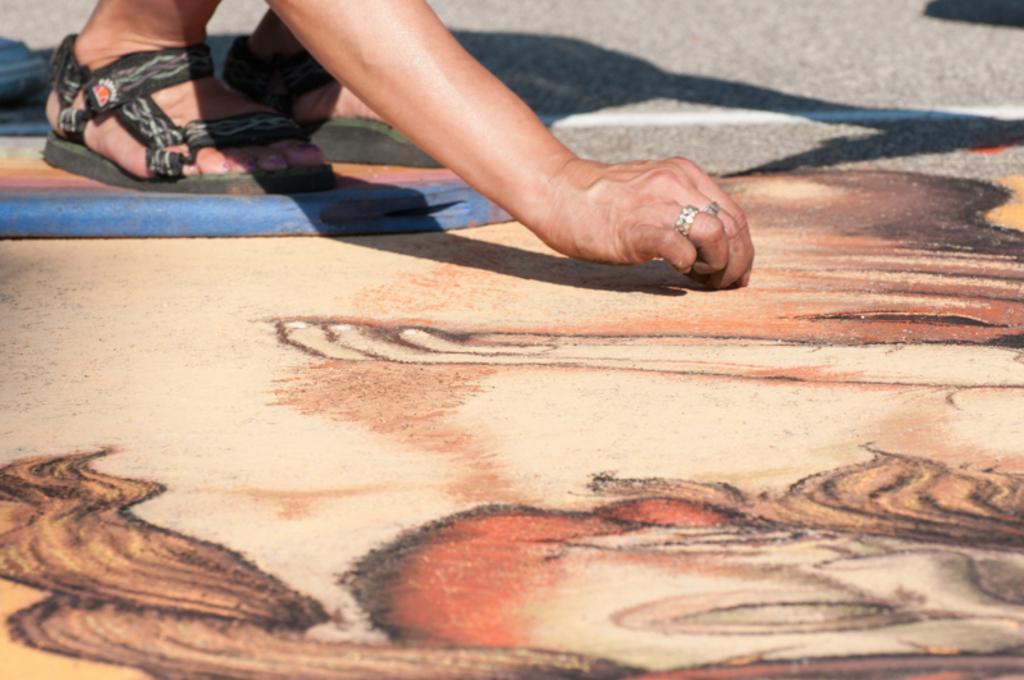Please provide a concise description of this image. In the image we can see a person wearing sandals and finger rings. Here we can see Rangoli and the road. 